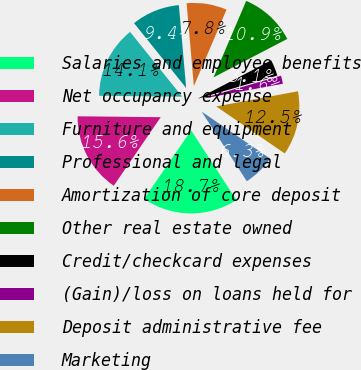<chart> <loc_0><loc_0><loc_500><loc_500><pie_chart><fcel>Salaries and employee benefits<fcel>Net occupancy expense<fcel>Furniture and equipment<fcel>Professional and legal<fcel>Amortization of core deposit<fcel>Other real estate owned<fcel>Credit/checkcard expenses<fcel>(Gain)/loss on loans held for<fcel>Deposit administrative fee<fcel>Marketing<nl><fcel>18.73%<fcel>15.61%<fcel>14.05%<fcel>9.38%<fcel>7.82%<fcel>10.93%<fcel>3.14%<fcel>1.59%<fcel>12.49%<fcel>6.26%<nl></chart> 